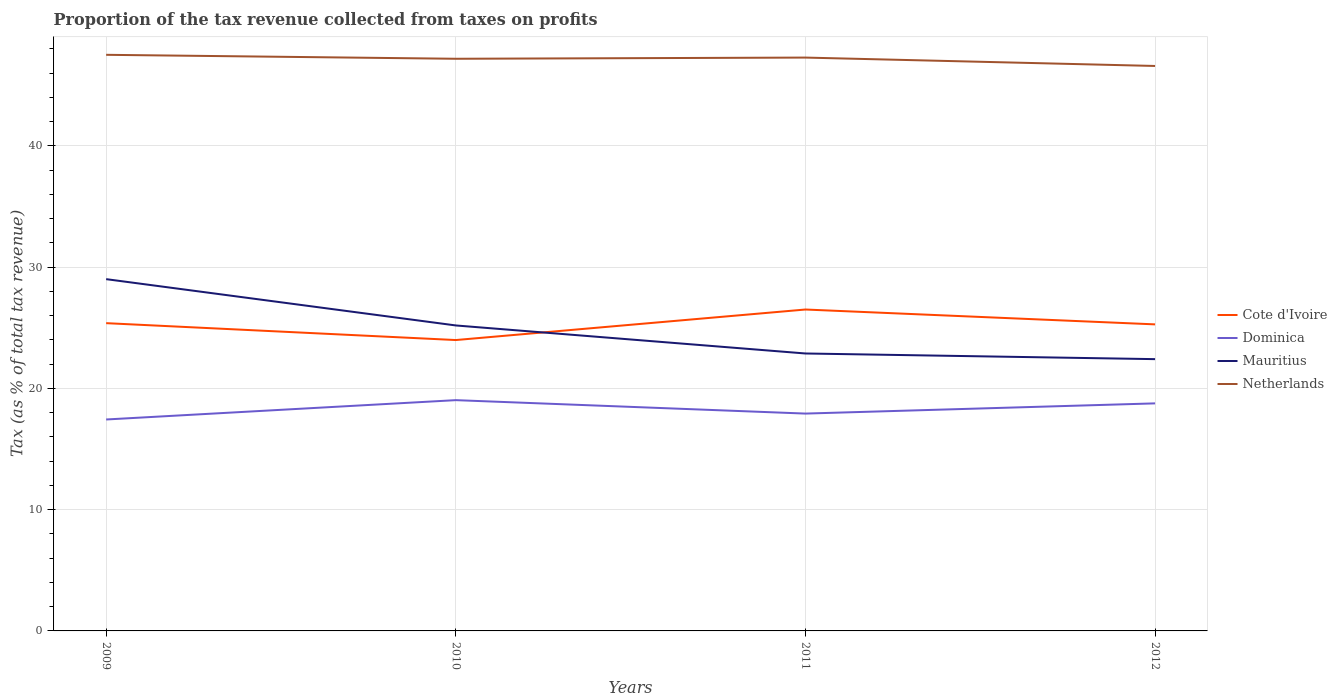How many different coloured lines are there?
Give a very brief answer. 4. Across all years, what is the maximum proportion of the tax revenue collected in Mauritius?
Offer a terse response. 22.41. In which year was the proportion of the tax revenue collected in Dominica maximum?
Give a very brief answer. 2009. What is the total proportion of the tax revenue collected in Mauritius in the graph?
Your response must be concise. 3.82. What is the difference between the highest and the second highest proportion of the tax revenue collected in Netherlands?
Provide a short and direct response. 0.92. Does the graph contain grids?
Your response must be concise. Yes. Where does the legend appear in the graph?
Ensure brevity in your answer.  Center right. What is the title of the graph?
Offer a terse response. Proportion of the tax revenue collected from taxes on profits. What is the label or title of the X-axis?
Make the answer very short. Years. What is the label or title of the Y-axis?
Provide a short and direct response. Tax (as % of total tax revenue). What is the Tax (as % of total tax revenue) of Cote d'Ivoire in 2009?
Provide a succinct answer. 25.38. What is the Tax (as % of total tax revenue) of Dominica in 2009?
Offer a very short reply. 17.44. What is the Tax (as % of total tax revenue) in Mauritius in 2009?
Provide a short and direct response. 29.01. What is the Tax (as % of total tax revenue) of Netherlands in 2009?
Offer a very short reply. 47.51. What is the Tax (as % of total tax revenue) of Cote d'Ivoire in 2010?
Offer a very short reply. 23.99. What is the Tax (as % of total tax revenue) in Dominica in 2010?
Ensure brevity in your answer.  19.03. What is the Tax (as % of total tax revenue) of Mauritius in 2010?
Offer a terse response. 25.19. What is the Tax (as % of total tax revenue) in Netherlands in 2010?
Your answer should be very brief. 47.18. What is the Tax (as % of total tax revenue) in Cote d'Ivoire in 2011?
Offer a very short reply. 26.5. What is the Tax (as % of total tax revenue) in Dominica in 2011?
Make the answer very short. 17.92. What is the Tax (as % of total tax revenue) of Mauritius in 2011?
Offer a very short reply. 22.88. What is the Tax (as % of total tax revenue) of Netherlands in 2011?
Give a very brief answer. 47.28. What is the Tax (as % of total tax revenue) in Cote d'Ivoire in 2012?
Offer a terse response. 25.28. What is the Tax (as % of total tax revenue) of Dominica in 2012?
Your answer should be very brief. 18.76. What is the Tax (as % of total tax revenue) in Mauritius in 2012?
Provide a short and direct response. 22.41. What is the Tax (as % of total tax revenue) in Netherlands in 2012?
Keep it short and to the point. 46.59. Across all years, what is the maximum Tax (as % of total tax revenue) of Cote d'Ivoire?
Provide a succinct answer. 26.5. Across all years, what is the maximum Tax (as % of total tax revenue) of Dominica?
Offer a terse response. 19.03. Across all years, what is the maximum Tax (as % of total tax revenue) in Mauritius?
Your answer should be compact. 29.01. Across all years, what is the maximum Tax (as % of total tax revenue) of Netherlands?
Provide a succinct answer. 47.51. Across all years, what is the minimum Tax (as % of total tax revenue) in Cote d'Ivoire?
Ensure brevity in your answer.  23.99. Across all years, what is the minimum Tax (as % of total tax revenue) in Dominica?
Make the answer very short. 17.44. Across all years, what is the minimum Tax (as % of total tax revenue) in Mauritius?
Keep it short and to the point. 22.41. Across all years, what is the minimum Tax (as % of total tax revenue) of Netherlands?
Provide a short and direct response. 46.59. What is the total Tax (as % of total tax revenue) in Cote d'Ivoire in the graph?
Offer a terse response. 101.15. What is the total Tax (as % of total tax revenue) of Dominica in the graph?
Offer a very short reply. 73.15. What is the total Tax (as % of total tax revenue) of Mauritius in the graph?
Your response must be concise. 99.49. What is the total Tax (as % of total tax revenue) in Netherlands in the graph?
Your answer should be compact. 188.56. What is the difference between the Tax (as % of total tax revenue) in Cote d'Ivoire in 2009 and that in 2010?
Your answer should be very brief. 1.39. What is the difference between the Tax (as % of total tax revenue) in Dominica in 2009 and that in 2010?
Your answer should be compact. -1.59. What is the difference between the Tax (as % of total tax revenue) of Mauritius in 2009 and that in 2010?
Keep it short and to the point. 3.82. What is the difference between the Tax (as % of total tax revenue) of Netherlands in 2009 and that in 2010?
Offer a very short reply. 0.33. What is the difference between the Tax (as % of total tax revenue) in Cote d'Ivoire in 2009 and that in 2011?
Ensure brevity in your answer.  -1.12. What is the difference between the Tax (as % of total tax revenue) in Dominica in 2009 and that in 2011?
Keep it short and to the point. -0.49. What is the difference between the Tax (as % of total tax revenue) in Mauritius in 2009 and that in 2011?
Your answer should be compact. 6.13. What is the difference between the Tax (as % of total tax revenue) of Netherlands in 2009 and that in 2011?
Offer a very short reply. 0.23. What is the difference between the Tax (as % of total tax revenue) in Cote d'Ivoire in 2009 and that in 2012?
Offer a terse response. 0.1. What is the difference between the Tax (as % of total tax revenue) of Dominica in 2009 and that in 2012?
Ensure brevity in your answer.  -1.33. What is the difference between the Tax (as % of total tax revenue) in Mauritius in 2009 and that in 2012?
Your answer should be compact. 6.6. What is the difference between the Tax (as % of total tax revenue) of Netherlands in 2009 and that in 2012?
Make the answer very short. 0.92. What is the difference between the Tax (as % of total tax revenue) in Cote d'Ivoire in 2010 and that in 2011?
Offer a very short reply. -2.52. What is the difference between the Tax (as % of total tax revenue) of Dominica in 2010 and that in 2011?
Keep it short and to the point. 1.11. What is the difference between the Tax (as % of total tax revenue) in Mauritius in 2010 and that in 2011?
Offer a terse response. 2.31. What is the difference between the Tax (as % of total tax revenue) of Netherlands in 2010 and that in 2011?
Your answer should be compact. -0.1. What is the difference between the Tax (as % of total tax revenue) in Cote d'Ivoire in 2010 and that in 2012?
Provide a short and direct response. -1.29. What is the difference between the Tax (as % of total tax revenue) in Dominica in 2010 and that in 2012?
Provide a succinct answer. 0.27. What is the difference between the Tax (as % of total tax revenue) of Mauritius in 2010 and that in 2012?
Offer a very short reply. 2.78. What is the difference between the Tax (as % of total tax revenue) of Netherlands in 2010 and that in 2012?
Ensure brevity in your answer.  0.59. What is the difference between the Tax (as % of total tax revenue) in Cote d'Ivoire in 2011 and that in 2012?
Ensure brevity in your answer.  1.23. What is the difference between the Tax (as % of total tax revenue) of Dominica in 2011 and that in 2012?
Give a very brief answer. -0.84. What is the difference between the Tax (as % of total tax revenue) of Mauritius in 2011 and that in 2012?
Offer a terse response. 0.47. What is the difference between the Tax (as % of total tax revenue) of Netherlands in 2011 and that in 2012?
Keep it short and to the point. 0.69. What is the difference between the Tax (as % of total tax revenue) in Cote d'Ivoire in 2009 and the Tax (as % of total tax revenue) in Dominica in 2010?
Offer a terse response. 6.35. What is the difference between the Tax (as % of total tax revenue) in Cote d'Ivoire in 2009 and the Tax (as % of total tax revenue) in Mauritius in 2010?
Your answer should be compact. 0.19. What is the difference between the Tax (as % of total tax revenue) of Cote d'Ivoire in 2009 and the Tax (as % of total tax revenue) of Netherlands in 2010?
Give a very brief answer. -21.8. What is the difference between the Tax (as % of total tax revenue) of Dominica in 2009 and the Tax (as % of total tax revenue) of Mauritius in 2010?
Your answer should be compact. -7.75. What is the difference between the Tax (as % of total tax revenue) of Dominica in 2009 and the Tax (as % of total tax revenue) of Netherlands in 2010?
Make the answer very short. -29.75. What is the difference between the Tax (as % of total tax revenue) of Mauritius in 2009 and the Tax (as % of total tax revenue) of Netherlands in 2010?
Offer a terse response. -18.17. What is the difference between the Tax (as % of total tax revenue) in Cote d'Ivoire in 2009 and the Tax (as % of total tax revenue) in Dominica in 2011?
Provide a short and direct response. 7.46. What is the difference between the Tax (as % of total tax revenue) in Cote d'Ivoire in 2009 and the Tax (as % of total tax revenue) in Mauritius in 2011?
Ensure brevity in your answer.  2.5. What is the difference between the Tax (as % of total tax revenue) of Cote d'Ivoire in 2009 and the Tax (as % of total tax revenue) of Netherlands in 2011?
Your answer should be compact. -21.9. What is the difference between the Tax (as % of total tax revenue) of Dominica in 2009 and the Tax (as % of total tax revenue) of Mauritius in 2011?
Your answer should be compact. -5.44. What is the difference between the Tax (as % of total tax revenue) in Dominica in 2009 and the Tax (as % of total tax revenue) in Netherlands in 2011?
Give a very brief answer. -29.84. What is the difference between the Tax (as % of total tax revenue) in Mauritius in 2009 and the Tax (as % of total tax revenue) in Netherlands in 2011?
Ensure brevity in your answer.  -18.27. What is the difference between the Tax (as % of total tax revenue) of Cote d'Ivoire in 2009 and the Tax (as % of total tax revenue) of Dominica in 2012?
Provide a short and direct response. 6.61. What is the difference between the Tax (as % of total tax revenue) of Cote d'Ivoire in 2009 and the Tax (as % of total tax revenue) of Mauritius in 2012?
Provide a short and direct response. 2.97. What is the difference between the Tax (as % of total tax revenue) of Cote d'Ivoire in 2009 and the Tax (as % of total tax revenue) of Netherlands in 2012?
Offer a terse response. -21.21. What is the difference between the Tax (as % of total tax revenue) in Dominica in 2009 and the Tax (as % of total tax revenue) in Mauritius in 2012?
Ensure brevity in your answer.  -4.98. What is the difference between the Tax (as % of total tax revenue) in Dominica in 2009 and the Tax (as % of total tax revenue) in Netherlands in 2012?
Offer a very short reply. -29.15. What is the difference between the Tax (as % of total tax revenue) in Mauritius in 2009 and the Tax (as % of total tax revenue) in Netherlands in 2012?
Your response must be concise. -17.58. What is the difference between the Tax (as % of total tax revenue) in Cote d'Ivoire in 2010 and the Tax (as % of total tax revenue) in Dominica in 2011?
Give a very brief answer. 6.06. What is the difference between the Tax (as % of total tax revenue) of Cote d'Ivoire in 2010 and the Tax (as % of total tax revenue) of Mauritius in 2011?
Offer a very short reply. 1.11. What is the difference between the Tax (as % of total tax revenue) in Cote d'Ivoire in 2010 and the Tax (as % of total tax revenue) in Netherlands in 2011?
Make the answer very short. -23.29. What is the difference between the Tax (as % of total tax revenue) of Dominica in 2010 and the Tax (as % of total tax revenue) of Mauritius in 2011?
Provide a short and direct response. -3.85. What is the difference between the Tax (as % of total tax revenue) of Dominica in 2010 and the Tax (as % of total tax revenue) of Netherlands in 2011?
Offer a terse response. -28.25. What is the difference between the Tax (as % of total tax revenue) in Mauritius in 2010 and the Tax (as % of total tax revenue) in Netherlands in 2011?
Offer a very short reply. -22.09. What is the difference between the Tax (as % of total tax revenue) in Cote d'Ivoire in 2010 and the Tax (as % of total tax revenue) in Dominica in 2012?
Your response must be concise. 5.22. What is the difference between the Tax (as % of total tax revenue) of Cote d'Ivoire in 2010 and the Tax (as % of total tax revenue) of Mauritius in 2012?
Keep it short and to the point. 1.57. What is the difference between the Tax (as % of total tax revenue) of Cote d'Ivoire in 2010 and the Tax (as % of total tax revenue) of Netherlands in 2012?
Make the answer very short. -22.6. What is the difference between the Tax (as % of total tax revenue) of Dominica in 2010 and the Tax (as % of total tax revenue) of Mauritius in 2012?
Your answer should be compact. -3.38. What is the difference between the Tax (as % of total tax revenue) in Dominica in 2010 and the Tax (as % of total tax revenue) in Netherlands in 2012?
Provide a succinct answer. -27.56. What is the difference between the Tax (as % of total tax revenue) in Mauritius in 2010 and the Tax (as % of total tax revenue) in Netherlands in 2012?
Provide a short and direct response. -21.4. What is the difference between the Tax (as % of total tax revenue) of Cote d'Ivoire in 2011 and the Tax (as % of total tax revenue) of Dominica in 2012?
Keep it short and to the point. 7.74. What is the difference between the Tax (as % of total tax revenue) in Cote d'Ivoire in 2011 and the Tax (as % of total tax revenue) in Mauritius in 2012?
Offer a very short reply. 4.09. What is the difference between the Tax (as % of total tax revenue) in Cote d'Ivoire in 2011 and the Tax (as % of total tax revenue) in Netherlands in 2012?
Keep it short and to the point. -20.08. What is the difference between the Tax (as % of total tax revenue) of Dominica in 2011 and the Tax (as % of total tax revenue) of Mauritius in 2012?
Offer a terse response. -4.49. What is the difference between the Tax (as % of total tax revenue) of Dominica in 2011 and the Tax (as % of total tax revenue) of Netherlands in 2012?
Offer a terse response. -28.67. What is the difference between the Tax (as % of total tax revenue) in Mauritius in 2011 and the Tax (as % of total tax revenue) in Netherlands in 2012?
Provide a short and direct response. -23.71. What is the average Tax (as % of total tax revenue) in Cote d'Ivoire per year?
Offer a very short reply. 25.29. What is the average Tax (as % of total tax revenue) of Dominica per year?
Offer a very short reply. 18.29. What is the average Tax (as % of total tax revenue) of Mauritius per year?
Provide a short and direct response. 24.87. What is the average Tax (as % of total tax revenue) of Netherlands per year?
Ensure brevity in your answer.  47.14. In the year 2009, what is the difference between the Tax (as % of total tax revenue) in Cote d'Ivoire and Tax (as % of total tax revenue) in Dominica?
Keep it short and to the point. 7.94. In the year 2009, what is the difference between the Tax (as % of total tax revenue) in Cote d'Ivoire and Tax (as % of total tax revenue) in Mauritius?
Ensure brevity in your answer.  -3.63. In the year 2009, what is the difference between the Tax (as % of total tax revenue) in Cote d'Ivoire and Tax (as % of total tax revenue) in Netherlands?
Give a very brief answer. -22.13. In the year 2009, what is the difference between the Tax (as % of total tax revenue) in Dominica and Tax (as % of total tax revenue) in Mauritius?
Keep it short and to the point. -11.57. In the year 2009, what is the difference between the Tax (as % of total tax revenue) of Dominica and Tax (as % of total tax revenue) of Netherlands?
Offer a terse response. -30.07. In the year 2009, what is the difference between the Tax (as % of total tax revenue) of Mauritius and Tax (as % of total tax revenue) of Netherlands?
Provide a succinct answer. -18.5. In the year 2010, what is the difference between the Tax (as % of total tax revenue) of Cote d'Ivoire and Tax (as % of total tax revenue) of Dominica?
Your answer should be compact. 4.96. In the year 2010, what is the difference between the Tax (as % of total tax revenue) of Cote d'Ivoire and Tax (as % of total tax revenue) of Mauritius?
Keep it short and to the point. -1.2. In the year 2010, what is the difference between the Tax (as % of total tax revenue) of Cote d'Ivoire and Tax (as % of total tax revenue) of Netherlands?
Your response must be concise. -23.2. In the year 2010, what is the difference between the Tax (as % of total tax revenue) of Dominica and Tax (as % of total tax revenue) of Mauritius?
Provide a succinct answer. -6.16. In the year 2010, what is the difference between the Tax (as % of total tax revenue) of Dominica and Tax (as % of total tax revenue) of Netherlands?
Your answer should be very brief. -28.15. In the year 2010, what is the difference between the Tax (as % of total tax revenue) in Mauritius and Tax (as % of total tax revenue) in Netherlands?
Make the answer very short. -21.99. In the year 2011, what is the difference between the Tax (as % of total tax revenue) of Cote d'Ivoire and Tax (as % of total tax revenue) of Dominica?
Keep it short and to the point. 8.58. In the year 2011, what is the difference between the Tax (as % of total tax revenue) of Cote d'Ivoire and Tax (as % of total tax revenue) of Mauritius?
Provide a short and direct response. 3.63. In the year 2011, what is the difference between the Tax (as % of total tax revenue) in Cote d'Ivoire and Tax (as % of total tax revenue) in Netherlands?
Provide a short and direct response. -20.78. In the year 2011, what is the difference between the Tax (as % of total tax revenue) of Dominica and Tax (as % of total tax revenue) of Mauritius?
Ensure brevity in your answer.  -4.96. In the year 2011, what is the difference between the Tax (as % of total tax revenue) in Dominica and Tax (as % of total tax revenue) in Netherlands?
Provide a succinct answer. -29.36. In the year 2011, what is the difference between the Tax (as % of total tax revenue) in Mauritius and Tax (as % of total tax revenue) in Netherlands?
Your answer should be very brief. -24.4. In the year 2012, what is the difference between the Tax (as % of total tax revenue) of Cote d'Ivoire and Tax (as % of total tax revenue) of Dominica?
Offer a terse response. 6.51. In the year 2012, what is the difference between the Tax (as % of total tax revenue) of Cote d'Ivoire and Tax (as % of total tax revenue) of Mauritius?
Your answer should be very brief. 2.87. In the year 2012, what is the difference between the Tax (as % of total tax revenue) of Cote d'Ivoire and Tax (as % of total tax revenue) of Netherlands?
Offer a very short reply. -21.31. In the year 2012, what is the difference between the Tax (as % of total tax revenue) in Dominica and Tax (as % of total tax revenue) in Mauritius?
Ensure brevity in your answer.  -3.65. In the year 2012, what is the difference between the Tax (as % of total tax revenue) of Dominica and Tax (as % of total tax revenue) of Netherlands?
Your answer should be very brief. -27.82. In the year 2012, what is the difference between the Tax (as % of total tax revenue) in Mauritius and Tax (as % of total tax revenue) in Netherlands?
Your answer should be compact. -24.18. What is the ratio of the Tax (as % of total tax revenue) of Cote d'Ivoire in 2009 to that in 2010?
Offer a terse response. 1.06. What is the ratio of the Tax (as % of total tax revenue) in Dominica in 2009 to that in 2010?
Offer a very short reply. 0.92. What is the ratio of the Tax (as % of total tax revenue) of Mauritius in 2009 to that in 2010?
Give a very brief answer. 1.15. What is the ratio of the Tax (as % of total tax revenue) in Netherlands in 2009 to that in 2010?
Give a very brief answer. 1.01. What is the ratio of the Tax (as % of total tax revenue) in Cote d'Ivoire in 2009 to that in 2011?
Provide a short and direct response. 0.96. What is the ratio of the Tax (as % of total tax revenue) in Dominica in 2009 to that in 2011?
Offer a very short reply. 0.97. What is the ratio of the Tax (as % of total tax revenue) in Mauritius in 2009 to that in 2011?
Make the answer very short. 1.27. What is the ratio of the Tax (as % of total tax revenue) in Dominica in 2009 to that in 2012?
Your answer should be compact. 0.93. What is the ratio of the Tax (as % of total tax revenue) in Mauritius in 2009 to that in 2012?
Provide a short and direct response. 1.29. What is the ratio of the Tax (as % of total tax revenue) in Netherlands in 2009 to that in 2012?
Your response must be concise. 1.02. What is the ratio of the Tax (as % of total tax revenue) of Cote d'Ivoire in 2010 to that in 2011?
Offer a terse response. 0.91. What is the ratio of the Tax (as % of total tax revenue) in Dominica in 2010 to that in 2011?
Your answer should be compact. 1.06. What is the ratio of the Tax (as % of total tax revenue) of Mauritius in 2010 to that in 2011?
Your answer should be compact. 1.1. What is the ratio of the Tax (as % of total tax revenue) of Netherlands in 2010 to that in 2011?
Provide a short and direct response. 1. What is the ratio of the Tax (as % of total tax revenue) in Cote d'Ivoire in 2010 to that in 2012?
Give a very brief answer. 0.95. What is the ratio of the Tax (as % of total tax revenue) of Dominica in 2010 to that in 2012?
Provide a short and direct response. 1.01. What is the ratio of the Tax (as % of total tax revenue) in Mauritius in 2010 to that in 2012?
Your response must be concise. 1.12. What is the ratio of the Tax (as % of total tax revenue) in Netherlands in 2010 to that in 2012?
Your answer should be compact. 1.01. What is the ratio of the Tax (as % of total tax revenue) in Cote d'Ivoire in 2011 to that in 2012?
Provide a short and direct response. 1.05. What is the ratio of the Tax (as % of total tax revenue) of Dominica in 2011 to that in 2012?
Make the answer very short. 0.96. What is the ratio of the Tax (as % of total tax revenue) in Mauritius in 2011 to that in 2012?
Offer a very short reply. 1.02. What is the ratio of the Tax (as % of total tax revenue) in Netherlands in 2011 to that in 2012?
Provide a short and direct response. 1.01. What is the difference between the highest and the second highest Tax (as % of total tax revenue) of Cote d'Ivoire?
Give a very brief answer. 1.12. What is the difference between the highest and the second highest Tax (as % of total tax revenue) of Dominica?
Your answer should be very brief. 0.27. What is the difference between the highest and the second highest Tax (as % of total tax revenue) in Mauritius?
Your answer should be compact. 3.82. What is the difference between the highest and the second highest Tax (as % of total tax revenue) in Netherlands?
Provide a succinct answer. 0.23. What is the difference between the highest and the lowest Tax (as % of total tax revenue) of Cote d'Ivoire?
Your response must be concise. 2.52. What is the difference between the highest and the lowest Tax (as % of total tax revenue) in Dominica?
Provide a succinct answer. 1.59. What is the difference between the highest and the lowest Tax (as % of total tax revenue) of Mauritius?
Make the answer very short. 6.6. What is the difference between the highest and the lowest Tax (as % of total tax revenue) of Netherlands?
Offer a terse response. 0.92. 